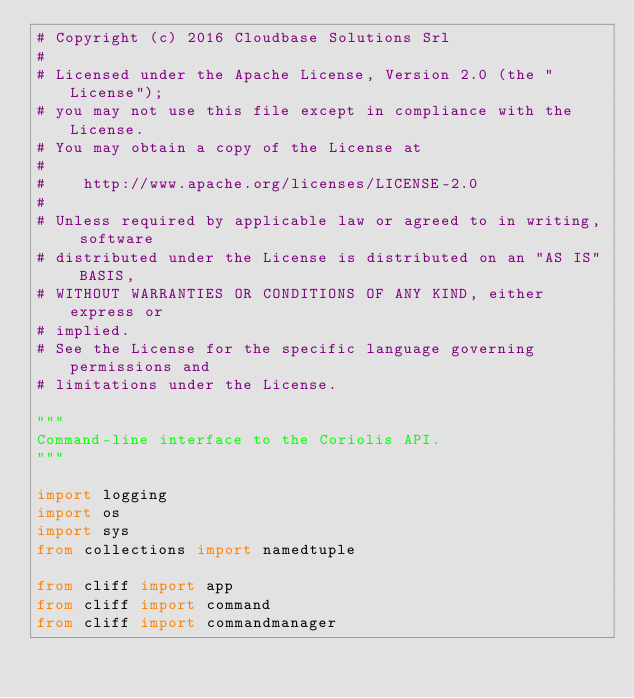Convert code to text. <code><loc_0><loc_0><loc_500><loc_500><_Python_># Copyright (c) 2016 Cloudbase Solutions Srl
#
# Licensed under the Apache License, Version 2.0 (the "License");
# you may not use this file except in compliance with the License.
# You may obtain a copy of the License at
#
#    http://www.apache.org/licenses/LICENSE-2.0
#
# Unless required by applicable law or agreed to in writing, software
# distributed under the License is distributed on an "AS IS" BASIS,
# WITHOUT WARRANTIES OR CONDITIONS OF ANY KIND, either express or
# implied.
# See the License for the specific language governing permissions and
# limitations under the License.

"""
Command-line interface to the Coriolis API.
"""

import logging
import os
import sys
from collections import namedtuple

from cliff import app
from cliff import command
from cliff import commandmanager</code> 